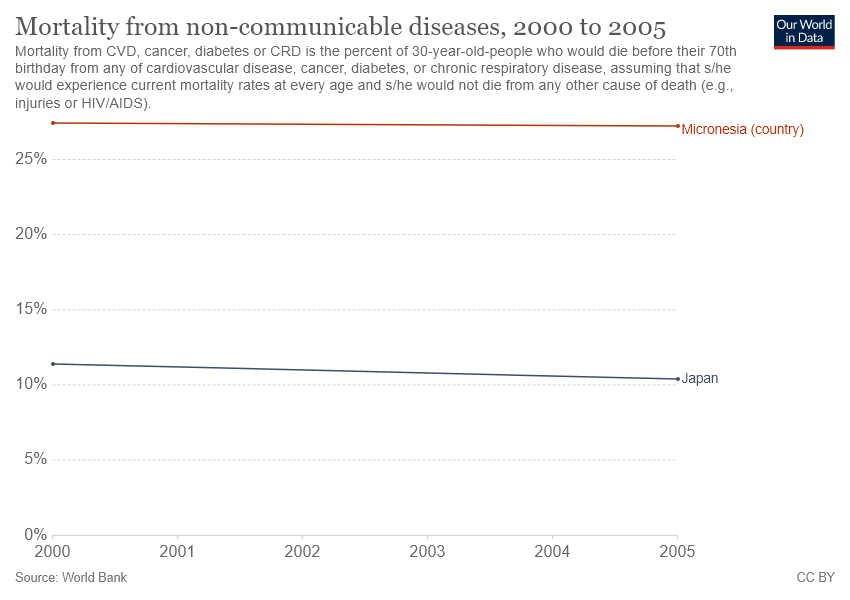Point out several critical features in this image. The given graph compares Micronesia and Japan. In 2005, Japan had the lowest mortality rate from non-communicable diseases among all years. 